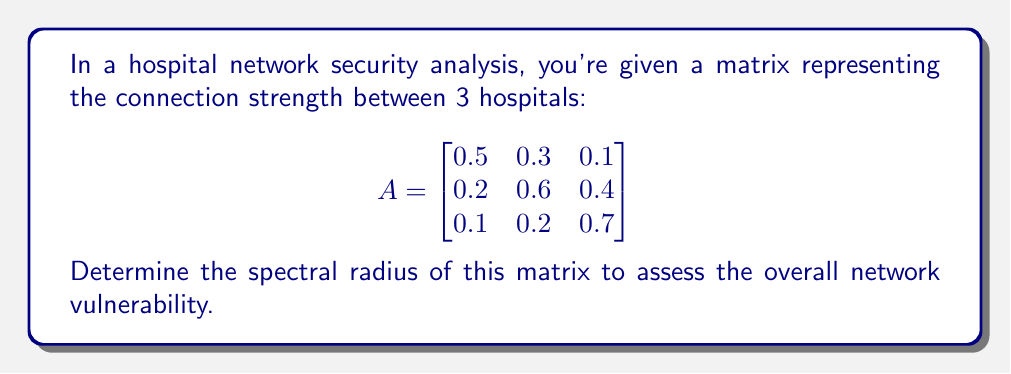Give your solution to this math problem. To find the spectral radius, we need to:

1. Find the characteristic equation:
   $det(A - \lambda I) = 0$

2. Expand the determinant:
   $$\begin{vmatrix}
   0.5-\lambda & 0.3 & 0.1 \\
   0.2 & 0.6-\lambda & 0.4 \\
   0.1 & 0.2 & 0.7-\lambda
   \end{vmatrix} = 0$$

3. Solve the equation:
   $(0.5-\lambda)(0.6-\lambda)(0.7-\lambda) - 0.3\cdot0.4\cdot0.1 - 0.1\cdot0.2\cdot0.2 - (0.5-\lambda)\cdot0.4\cdot0.2 - 0.3\cdot0.2\cdot(0.7-\lambda) - 0.1\cdot(0.6-\lambda)\cdot0.1 = 0$

4. Simplify:
   $-\lambda^3 + 1.8\lambda^2 - 0.97\lambda + 0.158 = 0$

5. Find the roots of this cubic equation. The largest absolute value of these roots is the spectral radius.

6. Using a numerical method (e.g., Newton-Raphson), we find the roots:
   $\lambda_1 \approx 0.9691$
   $\lambda_2 \approx 0.4655 + 0.0873i$
   $\lambda_3 \approx 0.4655 - 0.0873i$

7. The spectral radius is the maximum absolute value of these eigenvalues:
   $\rho(A) = \max(|\lambda_1|, |\lambda_2|, |\lambda_3|) = |\lambda_1| \approx 0.9691$
Answer: $0.9691$ 